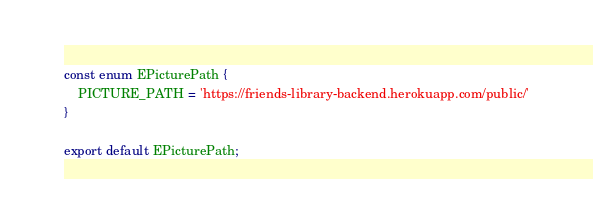Convert code to text. <code><loc_0><loc_0><loc_500><loc_500><_TypeScript_>const enum EPicturePath {
    PICTURE_PATH = 'https://friends-library-backend.herokuapp.com/public/'
}

export default EPicturePath;</code> 